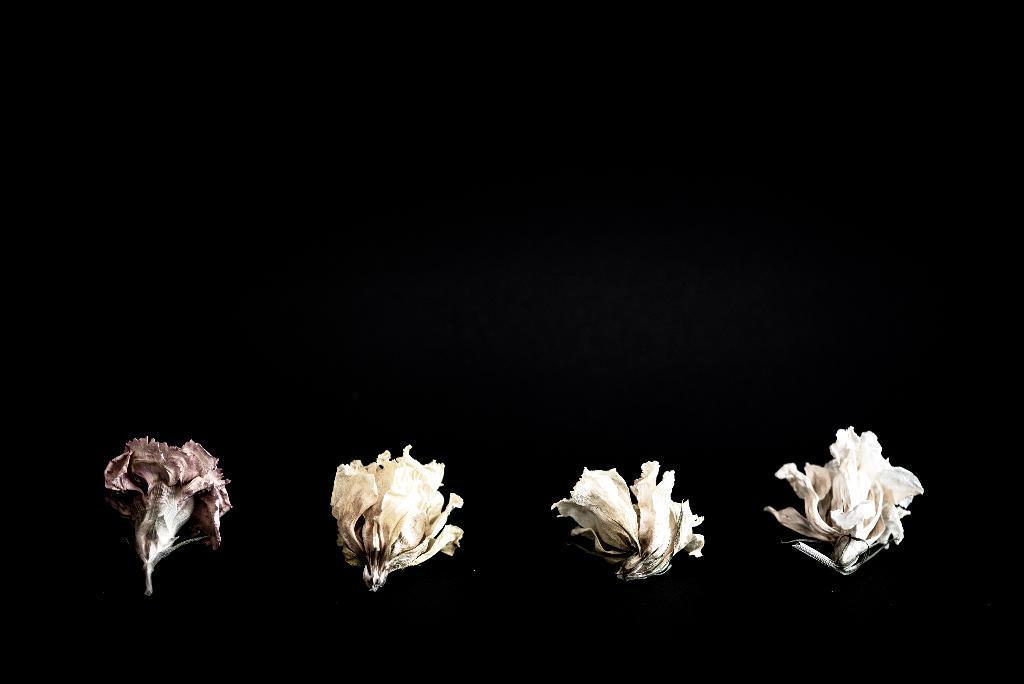Describe this image in one or two sentences. In this image we can see the flowers and the background is in black color. 